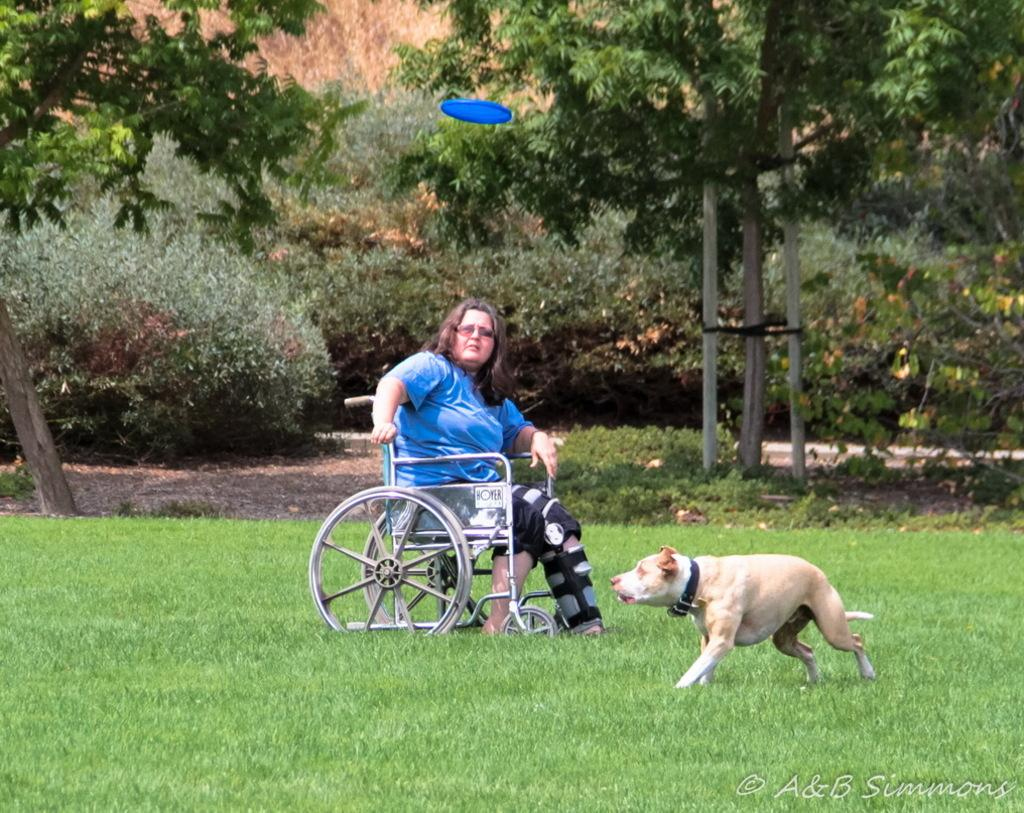What is the lady in the image sitting on? The lady in the image is sitting on a wheelchair. What type of terrain is visible at the bottom of the image? There is grass at the bottom of the image. What animal can be seen in the image? There is a dog visible in the image. What can be seen in the background of the image? There are trees and a disc visible in the background of the image. How many steps does the lady take while sitting on the wheelchair in the image? The lady does not take any steps while sitting on the wheelchair in the image, as she is stationary. 